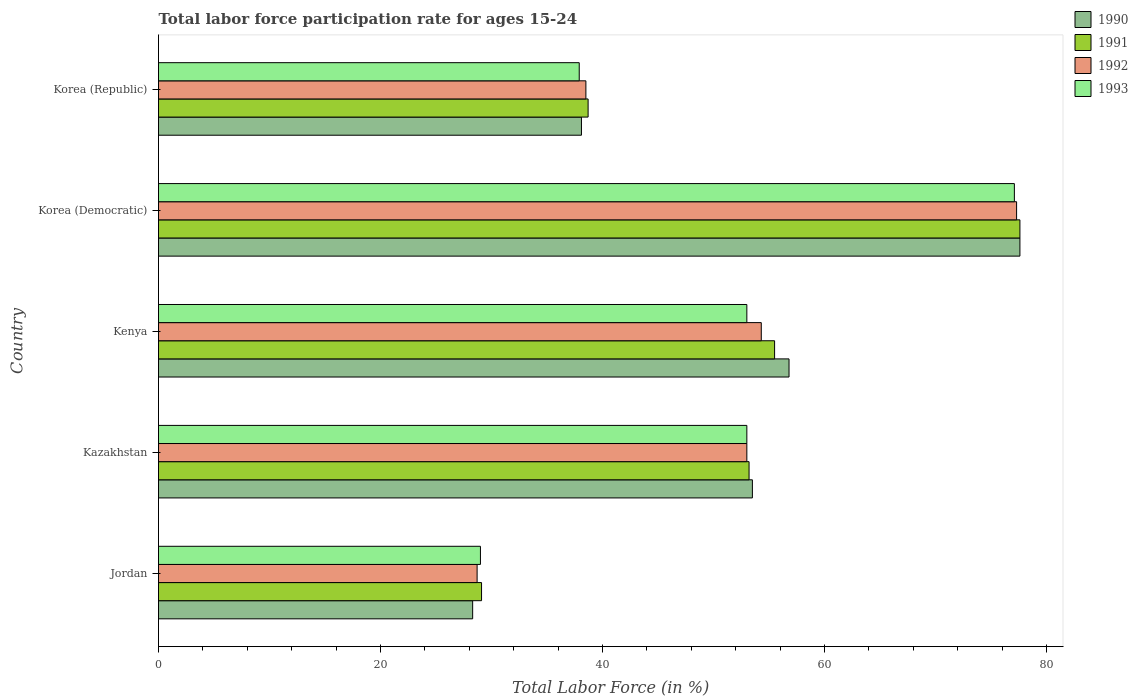How many different coloured bars are there?
Keep it short and to the point. 4. How many groups of bars are there?
Offer a terse response. 5. Are the number of bars per tick equal to the number of legend labels?
Provide a succinct answer. Yes. Are the number of bars on each tick of the Y-axis equal?
Offer a very short reply. Yes. How many bars are there on the 5th tick from the top?
Offer a very short reply. 4. How many bars are there on the 4th tick from the bottom?
Provide a succinct answer. 4. What is the label of the 3rd group of bars from the top?
Your answer should be very brief. Kenya. In how many cases, is the number of bars for a given country not equal to the number of legend labels?
Ensure brevity in your answer.  0. What is the labor force participation rate in 1992 in Kazakhstan?
Offer a very short reply. 53. Across all countries, what is the maximum labor force participation rate in 1993?
Give a very brief answer. 77.1. Across all countries, what is the minimum labor force participation rate in 1992?
Offer a terse response. 28.7. In which country was the labor force participation rate in 1990 maximum?
Make the answer very short. Korea (Democratic). In which country was the labor force participation rate in 1990 minimum?
Offer a very short reply. Jordan. What is the total labor force participation rate in 1992 in the graph?
Provide a succinct answer. 251.8. What is the difference between the labor force participation rate in 1992 in Kazakhstan and that in Kenya?
Provide a succinct answer. -1.3. What is the difference between the labor force participation rate in 1991 in Jordan and the labor force participation rate in 1992 in Korea (Democratic)?
Offer a very short reply. -48.2. What is the average labor force participation rate in 1992 per country?
Offer a very short reply. 50.36. What is the difference between the labor force participation rate in 1992 and labor force participation rate in 1991 in Kenya?
Keep it short and to the point. -1.2. What is the ratio of the labor force participation rate in 1992 in Jordan to that in Kazakhstan?
Offer a very short reply. 0.54. Is the labor force participation rate in 1992 in Jordan less than that in Kenya?
Keep it short and to the point. Yes. Is the difference between the labor force participation rate in 1992 in Kenya and Korea (Democratic) greater than the difference between the labor force participation rate in 1991 in Kenya and Korea (Democratic)?
Offer a very short reply. No. What is the difference between the highest and the second highest labor force participation rate in 1992?
Provide a short and direct response. 23. What is the difference between the highest and the lowest labor force participation rate in 1990?
Provide a succinct answer. 49.3. In how many countries, is the labor force participation rate in 1990 greater than the average labor force participation rate in 1990 taken over all countries?
Provide a succinct answer. 3. Is the sum of the labor force participation rate in 1992 in Kazakhstan and Korea (Democratic) greater than the maximum labor force participation rate in 1990 across all countries?
Offer a very short reply. Yes. Is it the case that in every country, the sum of the labor force participation rate in 1990 and labor force participation rate in 1993 is greater than the sum of labor force participation rate in 1991 and labor force participation rate in 1992?
Your answer should be very brief. No. What does the 1st bar from the bottom in Kenya represents?
Your answer should be very brief. 1990. How many bars are there?
Your response must be concise. 20. What is the difference between two consecutive major ticks on the X-axis?
Your answer should be compact. 20. Does the graph contain any zero values?
Your response must be concise. No. Does the graph contain grids?
Your response must be concise. No. How many legend labels are there?
Make the answer very short. 4. How are the legend labels stacked?
Give a very brief answer. Vertical. What is the title of the graph?
Your answer should be very brief. Total labor force participation rate for ages 15-24. Does "1976" appear as one of the legend labels in the graph?
Keep it short and to the point. No. What is the label or title of the X-axis?
Make the answer very short. Total Labor Force (in %). What is the label or title of the Y-axis?
Offer a terse response. Country. What is the Total Labor Force (in %) in 1990 in Jordan?
Your answer should be very brief. 28.3. What is the Total Labor Force (in %) of 1991 in Jordan?
Provide a succinct answer. 29.1. What is the Total Labor Force (in %) in 1992 in Jordan?
Your answer should be compact. 28.7. What is the Total Labor Force (in %) of 1993 in Jordan?
Offer a terse response. 29. What is the Total Labor Force (in %) of 1990 in Kazakhstan?
Ensure brevity in your answer.  53.5. What is the Total Labor Force (in %) of 1991 in Kazakhstan?
Your answer should be compact. 53.2. What is the Total Labor Force (in %) in 1990 in Kenya?
Your response must be concise. 56.8. What is the Total Labor Force (in %) of 1991 in Kenya?
Make the answer very short. 55.5. What is the Total Labor Force (in %) of 1992 in Kenya?
Provide a short and direct response. 54.3. What is the Total Labor Force (in %) in 1990 in Korea (Democratic)?
Your response must be concise. 77.6. What is the Total Labor Force (in %) of 1991 in Korea (Democratic)?
Offer a terse response. 77.6. What is the Total Labor Force (in %) in 1992 in Korea (Democratic)?
Your answer should be very brief. 77.3. What is the Total Labor Force (in %) in 1993 in Korea (Democratic)?
Give a very brief answer. 77.1. What is the Total Labor Force (in %) in 1990 in Korea (Republic)?
Keep it short and to the point. 38.1. What is the Total Labor Force (in %) of 1991 in Korea (Republic)?
Ensure brevity in your answer.  38.7. What is the Total Labor Force (in %) of 1992 in Korea (Republic)?
Give a very brief answer. 38.5. What is the Total Labor Force (in %) of 1993 in Korea (Republic)?
Offer a very short reply. 37.9. Across all countries, what is the maximum Total Labor Force (in %) in 1990?
Provide a succinct answer. 77.6. Across all countries, what is the maximum Total Labor Force (in %) in 1991?
Ensure brevity in your answer.  77.6. Across all countries, what is the maximum Total Labor Force (in %) of 1992?
Make the answer very short. 77.3. Across all countries, what is the maximum Total Labor Force (in %) in 1993?
Make the answer very short. 77.1. Across all countries, what is the minimum Total Labor Force (in %) in 1990?
Your response must be concise. 28.3. Across all countries, what is the minimum Total Labor Force (in %) of 1991?
Your response must be concise. 29.1. Across all countries, what is the minimum Total Labor Force (in %) of 1992?
Ensure brevity in your answer.  28.7. What is the total Total Labor Force (in %) of 1990 in the graph?
Your response must be concise. 254.3. What is the total Total Labor Force (in %) of 1991 in the graph?
Keep it short and to the point. 254.1. What is the total Total Labor Force (in %) in 1992 in the graph?
Give a very brief answer. 251.8. What is the total Total Labor Force (in %) in 1993 in the graph?
Offer a very short reply. 250. What is the difference between the Total Labor Force (in %) of 1990 in Jordan and that in Kazakhstan?
Ensure brevity in your answer.  -25.2. What is the difference between the Total Labor Force (in %) of 1991 in Jordan and that in Kazakhstan?
Offer a very short reply. -24.1. What is the difference between the Total Labor Force (in %) of 1992 in Jordan and that in Kazakhstan?
Give a very brief answer. -24.3. What is the difference between the Total Labor Force (in %) of 1993 in Jordan and that in Kazakhstan?
Provide a short and direct response. -24. What is the difference between the Total Labor Force (in %) in 1990 in Jordan and that in Kenya?
Provide a short and direct response. -28.5. What is the difference between the Total Labor Force (in %) in 1991 in Jordan and that in Kenya?
Offer a very short reply. -26.4. What is the difference between the Total Labor Force (in %) in 1992 in Jordan and that in Kenya?
Your response must be concise. -25.6. What is the difference between the Total Labor Force (in %) in 1990 in Jordan and that in Korea (Democratic)?
Give a very brief answer. -49.3. What is the difference between the Total Labor Force (in %) in 1991 in Jordan and that in Korea (Democratic)?
Your answer should be very brief. -48.5. What is the difference between the Total Labor Force (in %) of 1992 in Jordan and that in Korea (Democratic)?
Keep it short and to the point. -48.6. What is the difference between the Total Labor Force (in %) in 1993 in Jordan and that in Korea (Democratic)?
Give a very brief answer. -48.1. What is the difference between the Total Labor Force (in %) in 1993 in Jordan and that in Korea (Republic)?
Ensure brevity in your answer.  -8.9. What is the difference between the Total Labor Force (in %) of 1991 in Kazakhstan and that in Kenya?
Keep it short and to the point. -2.3. What is the difference between the Total Labor Force (in %) of 1990 in Kazakhstan and that in Korea (Democratic)?
Provide a succinct answer. -24.1. What is the difference between the Total Labor Force (in %) in 1991 in Kazakhstan and that in Korea (Democratic)?
Give a very brief answer. -24.4. What is the difference between the Total Labor Force (in %) in 1992 in Kazakhstan and that in Korea (Democratic)?
Ensure brevity in your answer.  -24.3. What is the difference between the Total Labor Force (in %) of 1993 in Kazakhstan and that in Korea (Democratic)?
Make the answer very short. -24.1. What is the difference between the Total Labor Force (in %) in 1990 in Kenya and that in Korea (Democratic)?
Your answer should be very brief. -20.8. What is the difference between the Total Labor Force (in %) of 1991 in Kenya and that in Korea (Democratic)?
Give a very brief answer. -22.1. What is the difference between the Total Labor Force (in %) of 1993 in Kenya and that in Korea (Democratic)?
Give a very brief answer. -24.1. What is the difference between the Total Labor Force (in %) in 1990 in Kenya and that in Korea (Republic)?
Give a very brief answer. 18.7. What is the difference between the Total Labor Force (in %) in 1993 in Kenya and that in Korea (Republic)?
Keep it short and to the point. 15.1. What is the difference between the Total Labor Force (in %) in 1990 in Korea (Democratic) and that in Korea (Republic)?
Your response must be concise. 39.5. What is the difference between the Total Labor Force (in %) in 1991 in Korea (Democratic) and that in Korea (Republic)?
Your answer should be compact. 38.9. What is the difference between the Total Labor Force (in %) in 1992 in Korea (Democratic) and that in Korea (Republic)?
Your answer should be compact. 38.8. What is the difference between the Total Labor Force (in %) of 1993 in Korea (Democratic) and that in Korea (Republic)?
Provide a short and direct response. 39.2. What is the difference between the Total Labor Force (in %) in 1990 in Jordan and the Total Labor Force (in %) in 1991 in Kazakhstan?
Make the answer very short. -24.9. What is the difference between the Total Labor Force (in %) in 1990 in Jordan and the Total Labor Force (in %) in 1992 in Kazakhstan?
Offer a terse response. -24.7. What is the difference between the Total Labor Force (in %) in 1990 in Jordan and the Total Labor Force (in %) in 1993 in Kazakhstan?
Your answer should be compact. -24.7. What is the difference between the Total Labor Force (in %) in 1991 in Jordan and the Total Labor Force (in %) in 1992 in Kazakhstan?
Offer a very short reply. -23.9. What is the difference between the Total Labor Force (in %) of 1991 in Jordan and the Total Labor Force (in %) of 1993 in Kazakhstan?
Ensure brevity in your answer.  -23.9. What is the difference between the Total Labor Force (in %) in 1992 in Jordan and the Total Labor Force (in %) in 1993 in Kazakhstan?
Give a very brief answer. -24.3. What is the difference between the Total Labor Force (in %) in 1990 in Jordan and the Total Labor Force (in %) in 1991 in Kenya?
Ensure brevity in your answer.  -27.2. What is the difference between the Total Labor Force (in %) of 1990 in Jordan and the Total Labor Force (in %) of 1992 in Kenya?
Your response must be concise. -26. What is the difference between the Total Labor Force (in %) of 1990 in Jordan and the Total Labor Force (in %) of 1993 in Kenya?
Provide a short and direct response. -24.7. What is the difference between the Total Labor Force (in %) of 1991 in Jordan and the Total Labor Force (in %) of 1992 in Kenya?
Offer a very short reply. -25.2. What is the difference between the Total Labor Force (in %) in 1991 in Jordan and the Total Labor Force (in %) in 1993 in Kenya?
Your answer should be very brief. -23.9. What is the difference between the Total Labor Force (in %) in 1992 in Jordan and the Total Labor Force (in %) in 1993 in Kenya?
Provide a short and direct response. -24.3. What is the difference between the Total Labor Force (in %) in 1990 in Jordan and the Total Labor Force (in %) in 1991 in Korea (Democratic)?
Your answer should be very brief. -49.3. What is the difference between the Total Labor Force (in %) of 1990 in Jordan and the Total Labor Force (in %) of 1992 in Korea (Democratic)?
Your answer should be compact. -49. What is the difference between the Total Labor Force (in %) in 1990 in Jordan and the Total Labor Force (in %) in 1993 in Korea (Democratic)?
Make the answer very short. -48.8. What is the difference between the Total Labor Force (in %) of 1991 in Jordan and the Total Labor Force (in %) of 1992 in Korea (Democratic)?
Offer a terse response. -48.2. What is the difference between the Total Labor Force (in %) in 1991 in Jordan and the Total Labor Force (in %) in 1993 in Korea (Democratic)?
Offer a terse response. -48. What is the difference between the Total Labor Force (in %) in 1992 in Jordan and the Total Labor Force (in %) in 1993 in Korea (Democratic)?
Make the answer very short. -48.4. What is the difference between the Total Labor Force (in %) of 1990 in Jordan and the Total Labor Force (in %) of 1992 in Korea (Republic)?
Offer a terse response. -10.2. What is the difference between the Total Labor Force (in %) in 1990 in Jordan and the Total Labor Force (in %) in 1993 in Korea (Republic)?
Keep it short and to the point. -9.6. What is the difference between the Total Labor Force (in %) in 1991 in Jordan and the Total Labor Force (in %) in 1993 in Korea (Republic)?
Provide a succinct answer. -8.8. What is the difference between the Total Labor Force (in %) of 1990 in Kazakhstan and the Total Labor Force (in %) of 1991 in Kenya?
Provide a short and direct response. -2. What is the difference between the Total Labor Force (in %) in 1990 in Kazakhstan and the Total Labor Force (in %) in 1992 in Kenya?
Keep it short and to the point. -0.8. What is the difference between the Total Labor Force (in %) in 1991 in Kazakhstan and the Total Labor Force (in %) in 1992 in Kenya?
Your response must be concise. -1.1. What is the difference between the Total Labor Force (in %) of 1992 in Kazakhstan and the Total Labor Force (in %) of 1993 in Kenya?
Provide a succinct answer. 0. What is the difference between the Total Labor Force (in %) in 1990 in Kazakhstan and the Total Labor Force (in %) in 1991 in Korea (Democratic)?
Offer a terse response. -24.1. What is the difference between the Total Labor Force (in %) of 1990 in Kazakhstan and the Total Labor Force (in %) of 1992 in Korea (Democratic)?
Your answer should be very brief. -23.8. What is the difference between the Total Labor Force (in %) in 1990 in Kazakhstan and the Total Labor Force (in %) in 1993 in Korea (Democratic)?
Make the answer very short. -23.6. What is the difference between the Total Labor Force (in %) in 1991 in Kazakhstan and the Total Labor Force (in %) in 1992 in Korea (Democratic)?
Ensure brevity in your answer.  -24.1. What is the difference between the Total Labor Force (in %) in 1991 in Kazakhstan and the Total Labor Force (in %) in 1993 in Korea (Democratic)?
Give a very brief answer. -23.9. What is the difference between the Total Labor Force (in %) of 1992 in Kazakhstan and the Total Labor Force (in %) of 1993 in Korea (Democratic)?
Offer a terse response. -24.1. What is the difference between the Total Labor Force (in %) of 1990 in Kazakhstan and the Total Labor Force (in %) of 1993 in Korea (Republic)?
Provide a succinct answer. 15.6. What is the difference between the Total Labor Force (in %) of 1991 in Kazakhstan and the Total Labor Force (in %) of 1992 in Korea (Republic)?
Your answer should be very brief. 14.7. What is the difference between the Total Labor Force (in %) of 1992 in Kazakhstan and the Total Labor Force (in %) of 1993 in Korea (Republic)?
Your answer should be very brief. 15.1. What is the difference between the Total Labor Force (in %) of 1990 in Kenya and the Total Labor Force (in %) of 1991 in Korea (Democratic)?
Your response must be concise. -20.8. What is the difference between the Total Labor Force (in %) in 1990 in Kenya and the Total Labor Force (in %) in 1992 in Korea (Democratic)?
Your answer should be very brief. -20.5. What is the difference between the Total Labor Force (in %) in 1990 in Kenya and the Total Labor Force (in %) in 1993 in Korea (Democratic)?
Keep it short and to the point. -20.3. What is the difference between the Total Labor Force (in %) in 1991 in Kenya and the Total Labor Force (in %) in 1992 in Korea (Democratic)?
Provide a succinct answer. -21.8. What is the difference between the Total Labor Force (in %) of 1991 in Kenya and the Total Labor Force (in %) of 1993 in Korea (Democratic)?
Your answer should be compact. -21.6. What is the difference between the Total Labor Force (in %) of 1992 in Kenya and the Total Labor Force (in %) of 1993 in Korea (Democratic)?
Your answer should be compact. -22.8. What is the difference between the Total Labor Force (in %) of 1990 in Kenya and the Total Labor Force (in %) of 1992 in Korea (Republic)?
Ensure brevity in your answer.  18.3. What is the difference between the Total Labor Force (in %) in 1991 in Kenya and the Total Labor Force (in %) in 1993 in Korea (Republic)?
Your answer should be compact. 17.6. What is the difference between the Total Labor Force (in %) in 1990 in Korea (Democratic) and the Total Labor Force (in %) in 1991 in Korea (Republic)?
Offer a terse response. 38.9. What is the difference between the Total Labor Force (in %) of 1990 in Korea (Democratic) and the Total Labor Force (in %) of 1992 in Korea (Republic)?
Your answer should be very brief. 39.1. What is the difference between the Total Labor Force (in %) in 1990 in Korea (Democratic) and the Total Labor Force (in %) in 1993 in Korea (Republic)?
Keep it short and to the point. 39.7. What is the difference between the Total Labor Force (in %) in 1991 in Korea (Democratic) and the Total Labor Force (in %) in 1992 in Korea (Republic)?
Ensure brevity in your answer.  39.1. What is the difference between the Total Labor Force (in %) of 1991 in Korea (Democratic) and the Total Labor Force (in %) of 1993 in Korea (Republic)?
Provide a short and direct response. 39.7. What is the difference between the Total Labor Force (in %) in 1992 in Korea (Democratic) and the Total Labor Force (in %) in 1993 in Korea (Republic)?
Provide a succinct answer. 39.4. What is the average Total Labor Force (in %) in 1990 per country?
Provide a succinct answer. 50.86. What is the average Total Labor Force (in %) of 1991 per country?
Offer a terse response. 50.82. What is the average Total Labor Force (in %) in 1992 per country?
Provide a short and direct response. 50.36. What is the average Total Labor Force (in %) in 1993 per country?
Offer a terse response. 50. What is the difference between the Total Labor Force (in %) of 1990 and Total Labor Force (in %) of 1991 in Jordan?
Your answer should be compact. -0.8. What is the difference between the Total Labor Force (in %) in 1990 and Total Labor Force (in %) in 1992 in Jordan?
Keep it short and to the point. -0.4. What is the difference between the Total Labor Force (in %) of 1991 and Total Labor Force (in %) of 1992 in Jordan?
Offer a terse response. 0.4. What is the difference between the Total Labor Force (in %) of 1992 and Total Labor Force (in %) of 1993 in Jordan?
Give a very brief answer. -0.3. What is the difference between the Total Labor Force (in %) of 1990 and Total Labor Force (in %) of 1991 in Kazakhstan?
Your answer should be compact. 0.3. What is the difference between the Total Labor Force (in %) in 1990 and Total Labor Force (in %) in 1992 in Kazakhstan?
Give a very brief answer. 0.5. What is the difference between the Total Labor Force (in %) in 1991 and Total Labor Force (in %) in 1992 in Kazakhstan?
Your response must be concise. 0.2. What is the difference between the Total Labor Force (in %) in 1991 and Total Labor Force (in %) in 1993 in Kazakhstan?
Make the answer very short. 0.2. What is the difference between the Total Labor Force (in %) in 1992 and Total Labor Force (in %) in 1993 in Kazakhstan?
Offer a very short reply. 0. What is the difference between the Total Labor Force (in %) of 1990 and Total Labor Force (in %) of 1991 in Kenya?
Provide a succinct answer. 1.3. What is the difference between the Total Labor Force (in %) of 1990 and Total Labor Force (in %) of 1992 in Kenya?
Make the answer very short. 2.5. What is the difference between the Total Labor Force (in %) in 1990 and Total Labor Force (in %) in 1993 in Kenya?
Keep it short and to the point. 3.8. What is the difference between the Total Labor Force (in %) of 1991 and Total Labor Force (in %) of 1993 in Kenya?
Your answer should be compact. 2.5. What is the difference between the Total Labor Force (in %) in 1992 and Total Labor Force (in %) in 1993 in Kenya?
Your answer should be very brief. 1.3. What is the difference between the Total Labor Force (in %) in 1990 and Total Labor Force (in %) in 1992 in Korea (Democratic)?
Keep it short and to the point. 0.3. What is the difference between the Total Labor Force (in %) of 1991 and Total Labor Force (in %) of 1993 in Korea (Democratic)?
Offer a very short reply. 0.5. What is the difference between the Total Labor Force (in %) in 1990 and Total Labor Force (in %) in 1992 in Korea (Republic)?
Keep it short and to the point. -0.4. What is the difference between the Total Labor Force (in %) of 1990 and Total Labor Force (in %) of 1993 in Korea (Republic)?
Offer a very short reply. 0.2. What is the difference between the Total Labor Force (in %) in 1991 and Total Labor Force (in %) in 1993 in Korea (Republic)?
Offer a terse response. 0.8. What is the difference between the Total Labor Force (in %) of 1992 and Total Labor Force (in %) of 1993 in Korea (Republic)?
Offer a terse response. 0.6. What is the ratio of the Total Labor Force (in %) of 1990 in Jordan to that in Kazakhstan?
Offer a very short reply. 0.53. What is the ratio of the Total Labor Force (in %) in 1991 in Jordan to that in Kazakhstan?
Make the answer very short. 0.55. What is the ratio of the Total Labor Force (in %) in 1992 in Jordan to that in Kazakhstan?
Your answer should be very brief. 0.54. What is the ratio of the Total Labor Force (in %) of 1993 in Jordan to that in Kazakhstan?
Make the answer very short. 0.55. What is the ratio of the Total Labor Force (in %) in 1990 in Jordan to that in Kenya?
Offer a very short reply. 0.5. What is the ratio of the Total Labor Force (in %) in 1991 in Jordan to that in Kenya?
Keep it short and to the point. 0.52. What is the ratio of the Total Labor Force (in %) of 1992 in Jordan to that in Kenya?
Your answer should be very brief. 0.53. What is the ratio of the Total Labor Force (in %) of 1993 in Jordan to that in Kenya?
Offer a terse response. 0.55. What is the ratio of the Total Labor Force (in %) in 1990 in Jordan to that in Korea (Democratic)?
Provide a short and direct response. 0.36. What is the ratio of the Total Labor Force (in %) in 1992 in Jordan to that in Korea (Democratic)?
Give a very brief answer. 0.37. What is the ratio of the Total Labor Force (in %) of 1993 in Jordan to that in Korea (Democratic)?
Provide a short and direct response. 0.38. What is the ratio of the Total Labor Force (in %) in 1990 in Jordan to that in Korea (Republic)?
Provide a succinct answer. 0.74. What is the ratio of the Total Labor Force (in %) of 1991 in Jordan to that in Korea (Republic)?
Give a very brief answer. 0.75. What is the ratio of the Total Labor Force (in %) of 1992 in Jordan to that in Korea (Republic)?
Give a very brief answer. 0.75. What is the ratio of the Total Labor Force (in %) in 1993 in Jordan to that in Korea (Republic)?
Provide a succinct answer. 0.77. What is the ratio of the Total Labor Force (in %) of 1990 in Kazakhstan to that in Kenya?
Give a very brief answer. 0.94. What is the ratio of the Total Labor Force (in %) in 1991 in Kazakhstan to that in Kenya?
Keep it short and to the point. 0.96. What is the ratio of the Total Labor Force (in %) in 1992 in Kazakhstan to that in Kenya?
Provide a succinct answer. 0.98. What is the ratio of the Total Labor Force (in %) of 1993 in Kazakhstan to that in Kenya?
Offer a terse response. 1. What is the ratio of the Total Labor Force (in %) in 1990 in Kazakhstan to that in Korea (Democratic)?
Your answer should be compact. 0.69. What is the ratio of the Total Labor Force (in %) in 1991 in Kazakhstan to that in Korea (Democratic)?
Offer a very short reply. 0.69. What is the ratio of the Total Labor Force (in %) in 1992 in Kazakhstan to that in Korea (Democratic)?
Your answer should be compact. 0.69. What is the ratio of the Total Labor Force (in %) in 1993 in Kazakhstan to that in Korea (Democratic)?
Offer a terse response. 0.69. What is the ratio of the Total Labor Force (in %) of 1990 in Kazakhstan to that in Korea (Republic)?
Offer a terse response. 1.4. What is the ratio of the Total Labor Force (in %) in 1991 in Kazakhstan to that in Korea (Republic)?
Ensure brevity in your answer.  1.37. What is the ratio of the Total Labor Force (in %) in 1992 in Kazakhstan to that in Korea (Republic)?
Keep it short and to the point. 1.38. What is the ratio of the Total Labor Force (in %) of 1993 in Kazakhstan to that in Korea (Republic)?
Keep it short and to the point. 1.4. What is the ratio of the Total Labor Force (in %) of 1990 in Kenya to that in Korea (Democratic)?
Your response must be concise. 0.73. What is the ratio of the Total Labor Force (in %) in 1991 in Kenya to that in Korea (Democratic)?
Keep it short and to the point. 0.72. What is the ratio of the Total Labor Force (in %) in 1992 in Kenya to that in Korea (Democratic)?
Keep it short and to the point. 0.7. What is the ratio of the Total Labor Force (in %) in 1993 in Kenya to that in Korea (Democratic)?
Give a very brief answer. 0.69. What is the ratio of the Total Labor Force (in %) of 1990 in Kenya to that in Korea (Republic)?
Your response must be concise. 1.49. What is the ratio of the Total Labor Force (in %) of 1991 in Kenya to that in Korea (Republic)?
Ensure brevity in your answer.  1.43. What is the ratio of the Total Labor Force (in %) in 1992 in Kenya to that in Korea (Republic)?
Your answer should be very brief. 1.41. What is the ratio of the Total Labor Force (in %) of 1993 in Kenya to that in Korea (Republic)?
Give a very brief answer. 1.4. What is the ratio of the Total Labor Force (in %) of 1990 in Korea (Democratic) to that in Korea (Republic)?
Your answer should be very brief. 2.04. What is the ratio of the Total Labor Force (in %) in 1991 in Korea (Democratic) to that in Korea (Republic)?
Make the answer very short. 2.01. What is the ratio of the Total Labor Force (in %) in 1992 in Korea (Democratic) to that in Korea (Republic)?
Provide a succinct answer. 2.01. What is the ratio of the Total Labor Force (in %) in 1993 in Korea (Democratic) to that in Korea (Republic)?
Offer a terse response. 2.03. What is the difference between the highest and the second highest Total Labor Force (in %) in 1990?
Your answer should be compact. 20.8. What is the difference between the highest and the second highest Total Labor Force (in %) in 1991?
Offer a terse response. 22.1. What is the difference between the highest and the second highest Total Labor Force (in %) of 1993?
Offer a very short reply. 24.1. What is the difference between the highest and the lowest Total Labor Force (in %) in 1990?
Offer a very short reply. 49.3. What is the difference between the highest and the lowest Total Labor Force (in %) in 1991?
Make the answer very short. 48.5. What is the difference between the highest and the lowest Total Labor Force (in %) of 1992?
Offer a terse response. 48.6. What is the difference between the highest and the lowest Total Labor Force (in %) in 1993?
Provide a succinct answer. 48.1. 